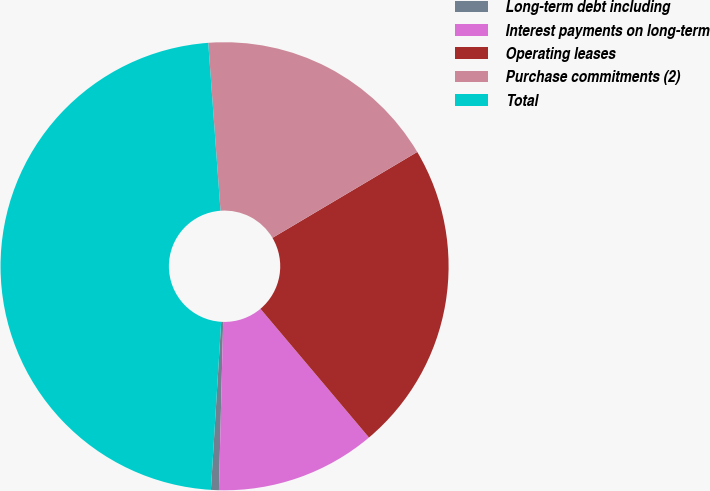Convert chart to OTSL. <chart><loc_0><loc_0><loc_500><loc_500><pie_chart><fcel>Long-term debt including<fcel>Interest payments on long-term<fcel>Operating leases<fcel>Purchase commitments (2)<fcel>Total<nl><fcel>0.57%<fcel>11.55%<fcel>22.37%<fcel>17.64%<fcel>47.87%<nl></chart> 